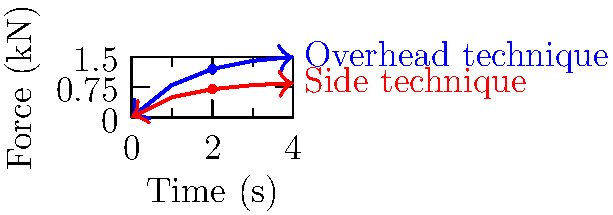In the graph above, two hammering techniques used in metalworking are compared: the overhead technique (blue) and the side technique (red). Based on the force-time curves, which technique is more biomechanically efficient for a steelworker, and why? To determine which technique is more biomechanically efficient, we need to consider several factors:

1. Peak force: The overhead technique reaches a higher peak force (approximately 1.5 kN) compared to the side technique (approximately 0.85 kN). This suggests that the overhead technique can deliver more force to the workpiece.

2. Rate of force development: The overhead technique shows a steeper initial slope, indicating a faster rate of force development. This is beneficial for impact-based tasks like hammering.

3. Impulse: The impulse is represented by the area under the force-time curve. The overhead technique has a larger area, indicating a greater impulse and potentially more energy transfer to the workpiece.

4. Force consistency: The overhead technique maintains a higher force for a longer duration, which can be advantageous for sustained hammering tasks.

5. Biomechanical considerations: The overhead technique likely utilizes more of the body's larger muscle groups and gravity to generate force, potentially reducing the strain on smaller muscle groups.

Given these factors, the overhead technique appears to be more biomechanically efficient for a steelworker. It provides higher peak force, faster force development, greater impulse, and better force consistency. These characteristics allow for more effective energy transfer to the workpiece and potentially less fatigue over extended periods of work.

However, it's important to note that individual factors such as worker height, strength, and the specific task at hand may influence the optimal technique for a given situation.
Answer: Overhead technique; higher peak force, faster force development, greater impulse. 